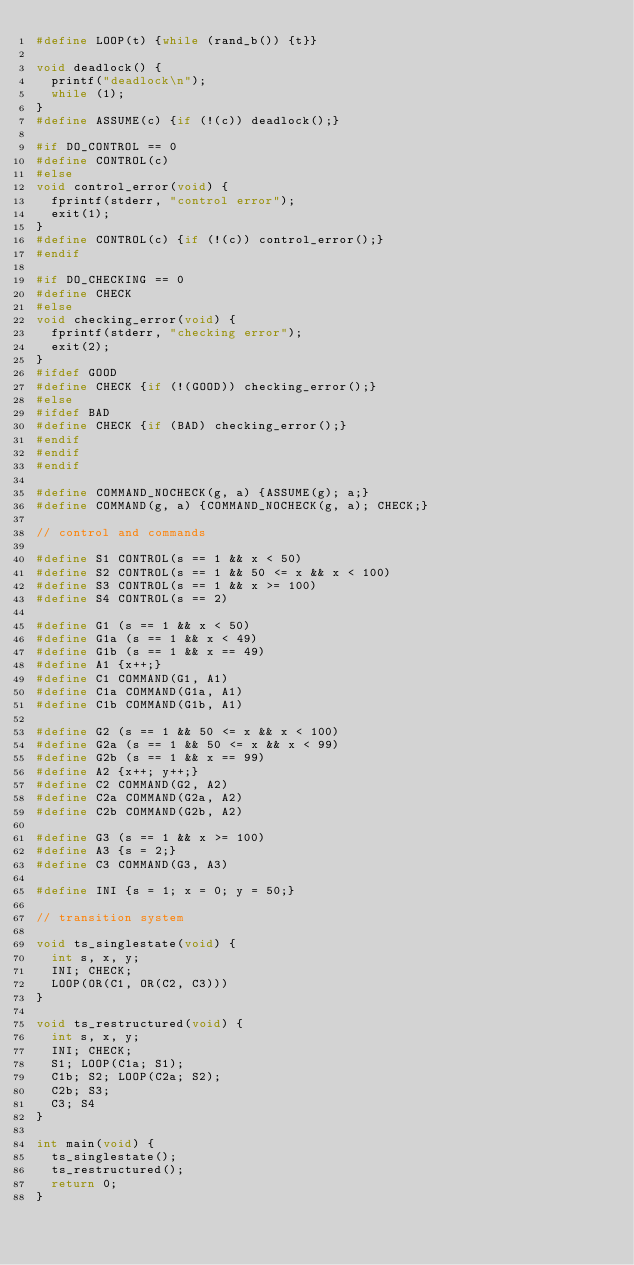<code> <loc_0><loc_0><loc_500><loc_500><_C_>#define LOOP(t) {while (rand_b()) {t}}

void deadlock() {
	printf("deadlock\n");
	while (1);
}
#define ASSUME(c) {if (!(c)) deadlock();}

#if DO_CONTROL == 0
#define CONTROL(c)
#else
void control_error(void) {
	fprintf(stderr, "control error");
	exit(1);
}
#define CONTROL(c) {if (!(c)) control_error();}
#endif

#if DO_CHECKING == 0
#define CHECK
#else
void checking_error(void) {
	fprintf(stderr, "checking error");
	exit(2);
}
#ifdef GOOD
#define CHECK {if (!(GOOD)) checking_error();}
#else
#ifdef BAD
#define CHECK {if (BAD) checking_error();}
#endif
#endif
#endif

#define COMMAND_NOCHECK(g, a) {ASSUME(g); a;}
#define COMMAND(g, a) {COMMAND_NOCHECK(g, a); CHECK;}

// control and commands

#define S1 CONTROL(s == 1 && x < 50)
#define S2 CONTROL(s == 1 && 50 <= x && x < 100)
#define S3 CONTROL(s == 1 && x >= 100)
#define S4 CONTROL(s == 2)

#define G1 (s == 1 && x < 50)
#define G1a (s == 1 && x < 49)
#define G1b (s == 1 && x == 49)
#define A1 {x++;}
#define C1 COMMAND(G1, A1)
#define C1a COMMAND(G1a, A1)
#define C1b COMMAND(G1b, A1)

#define G2 (s == 1 && 50 <= x && x < 100)
#define G2a (s == 1 && 50 <= x && x < 99)
#define G2b (s == 1 && x == 99)
#define A2 {x++; y++;}
#define C2 COMMAND(G2, A2)
#define C2a COMMAND(G2a, A2)
#define C2b COMMAND(G2b, A2)

#define G3 (s == 1 && x >= 100)
#define A3 {s = 2;}
#define C3 COMMAND(G3, A3)

#define INI {s = 1; x = 0; y = 50;}

// transition system

void ts_singlestate(void) {
	int s, x, y;
	INI; CHECK;
	LOOP(OR(C1, OR(C2, C3)))
}

void ts_restructured(void) {
	int s, x, y;
	INI; CHECK;
	S1; LOOP(C1a; S1);
	C1b; S2; LOOP(C2a; S2);
	C2b; S3;
	C3; S4
}

int main(void) {
	ts_singlestate();
	ts_restructured();
	return 0;
}

</code> 